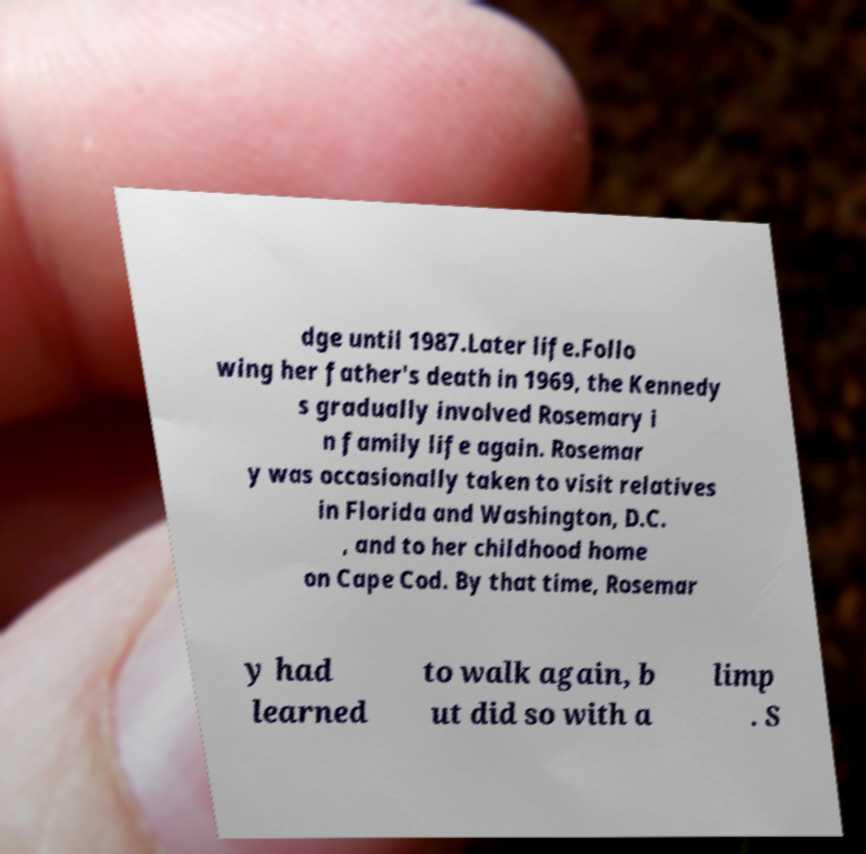For documentation purposes, I need the text within this image transcribed. Could you provide that? dge until 1987.Later life.Follo wing her father's death in 1969, the Kennedy s gradually involved Rosemary i n family life again. Rosemar y was occasionally taken to visit relatives in Florida and Washington, D.C. , and to her childhood home on Cape Cod. By that time, Rosemar y had learned to walk again, b ut did so with a limp . S 